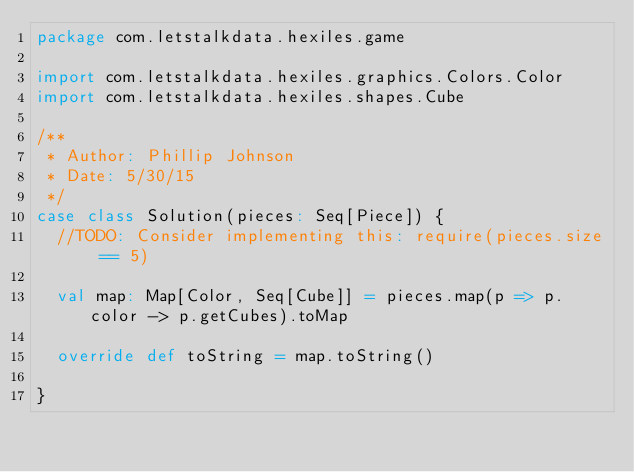Convert code to text. <code><loc_0><loc_0><loc_500><loc_500><_Scala_>package com.letstalkdata.hexiles.game

import com.letstalkdata.hexiles.graphics.Colors.Color
import com.letstalkdata.hexiles.shapes.Cube

/**
 * Author: Phillip Johnson
 * Date: 5/30/15
 */
case class Solution(pieces: Seq[Piece]) {
  //TODO: Consider implementing this: require(pieces.size == 5)

  val map: Map[Color, Seq[Cube]] = pieces.map(p => p.color -> p.getCubes).toMap

  override def toString = map.toString()

}
</code> 